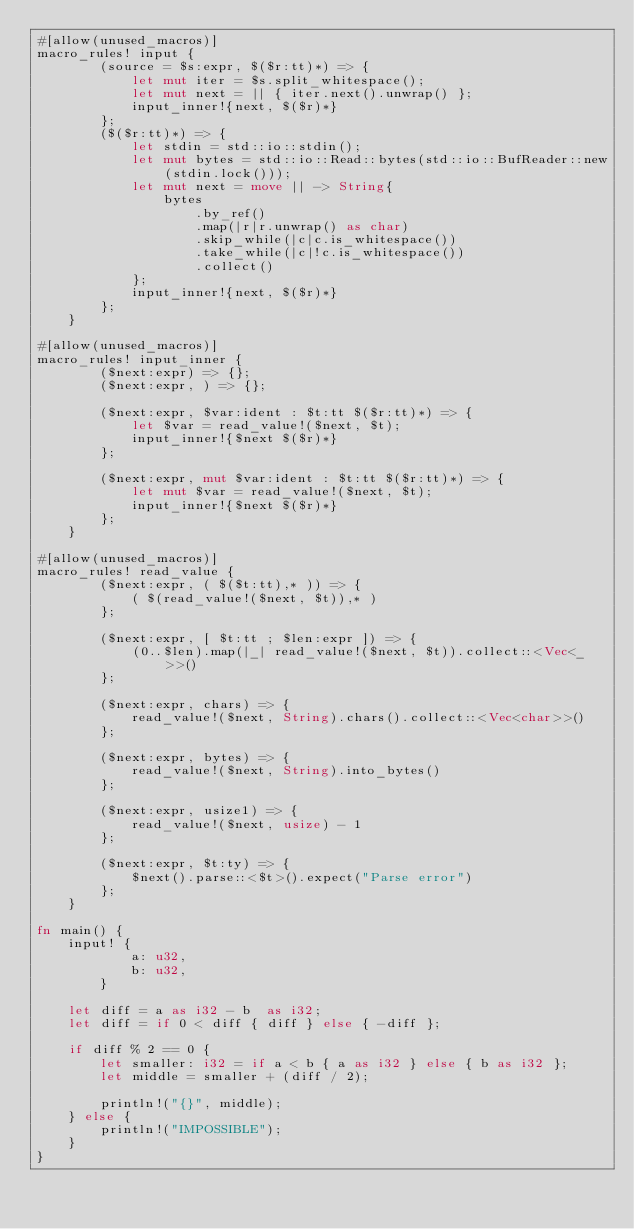<code> <loc_0><loc_0><loc_500><loc_500><_Rust_>#[allow(unused_macros)]
macro_rules! input {
        (source = $s:expr, $($r:tt)*) => {
            let mut iter = $s.split_whitespace();
            let mut next = || { iter.next().unwrap() };
            input_inner!{next, $($r)*}
        };
        ($($r:tt)*) => {
            let stdin = std::io::stdin();
            let mut bytes = std::io::Read::bytes(std::io::BufReader::new(stdin.lock()));
            let mut next = move || -> String{
                bytes
                    .by_ref()
                    .map(|r|r.unwrap() as char)
                    .skip_while(|c|c.is_whitespace())
                    .take_while(|c|!c.is_whitespace())
                    .collect()
            };
            input_inner!{next, $($r)*}
        };
    }

#[allow(unused_macros)]
macro_rules! input_inner {
        ($next:expr) => {};
        ($next:expr, ) => {};

        ($next:expr, $var:ident : $t:tt $($r:tt)*) => {
            let $var = read_value!($next, $t);
            input_inner!{$next $($r)*}
        };

        ($next:expr, mut $var:ident : $t:tt $($r:tt)*) => {
            let mut $var = read_value!($next, $t);
            input_inner!{$next $($r)*}
        };
    }

#[allow(unused_macros)]
macro_rules! read_value {
        ($next:expr, ( $($t:tt),* )) => {
            ( $(read_value!($next, $t)),* )
        };

        ($next:expr, [ $t:tt ; $len:expr ]) => {
            (0..$len).map(|_| read_value!($next, $t)).collect::<Vec<_>>()
        };

        ($next:expr, chars) => {
            read_value!($next, String).chars().collect::<Vec<char>>()
        };

        ($next:expr, bytes) => {
            read_value!($next, String).into_bytes()
        };

        ($next:expr, usize1) => {
            read_value!($next, usize) - 1
        };

        ($next:expr, $t:ty) => {
            $next().parse::<$t>().expect("Parse error")
        };
    }

fn main() {
    input! {
            a: u32,
            b: u32,
        }

    let diff = a as i32 - b  as i32;
    let diff = if 0 < diff { diff } else { -diff };

    if diff % 2 == 0 {
        let smaller: i32 = if a < b { a as i32 } else { b as i32 };
        let middle = smaller + (diff / 2);

        println!("{}", middle);
    } else {
        println!("IMPOSSIBLE");
    }
}</code> 